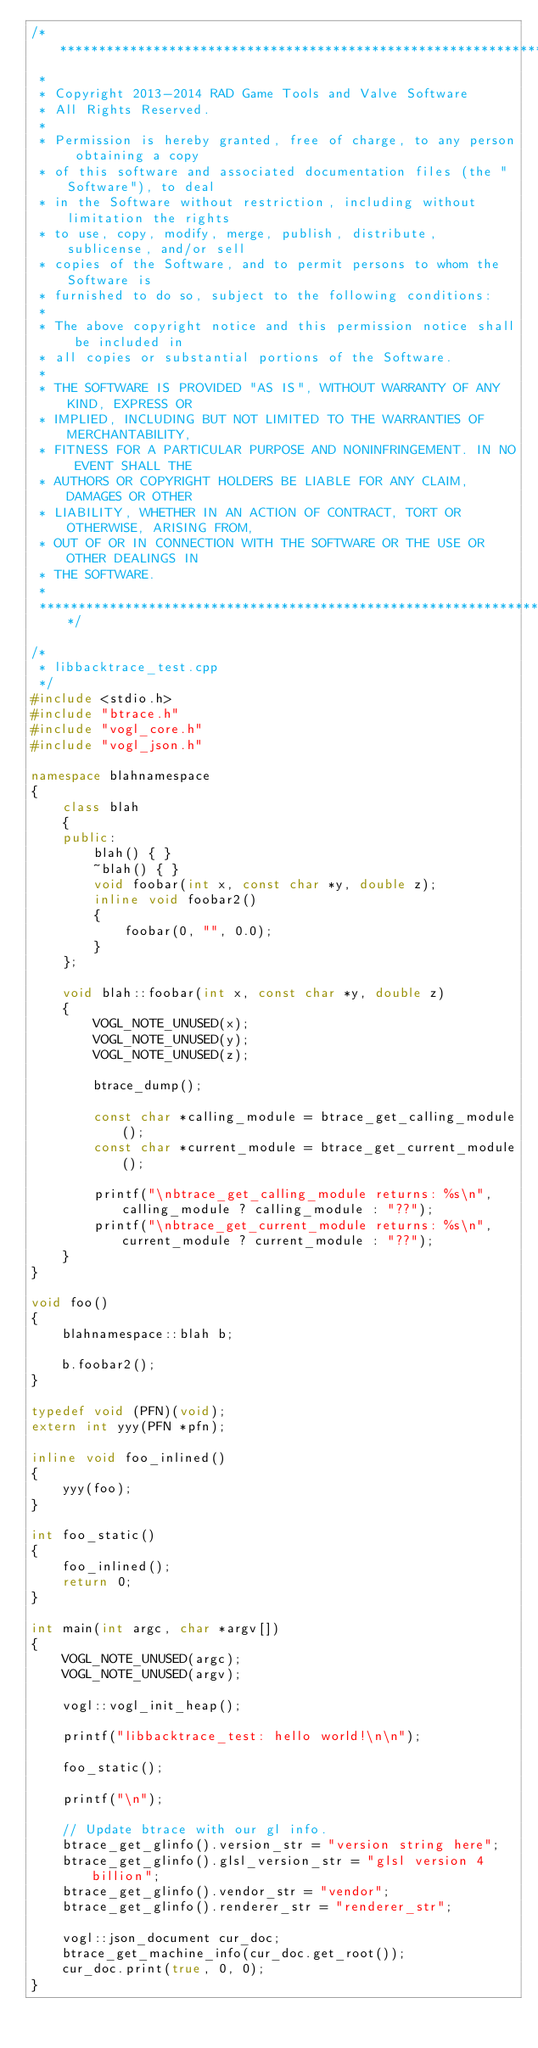<code> <loc_0><loc_0><loc_500><loc_500><_C++_>/**************************************************************************
 *
 * Copyright 2013-2014 RAD Game Tools and Valve Software
 * All Rights Reserved.
 *
 * Permission is hereby granted, free of charge, to any person obtaining a copy
 * of this software and associated documentation files (the "Software"), to deal
 * in the Software without restriction, including without limitation the rights
 * to use, copy, modify, merge, publish, distribute, sublicense, and/or sell
 * copies of the Software, and to permit persons to whom the Software is
 * furnished to do so, subject to the following conditions:
 *
 * The above copyright notice and this permission notice shall be included in
 * all copies or substantial portions of the Software.
 *
 * THE SOFTWARE IS PROVIDED "AS IS", WITHOUT WARRANTY OF ANY KIND, EXPRESS OR
 * IMPLIED, INCLUDING BUT NOT LIMITED TO THE WARRANTIES OF MERCHANTABILITY,
 * FITNESS FOR A PARTICULAR PURPOSE AND NONINFRINGEMENT. IN NO EVENT SHALL THE
 * AUTHORS OR COPYRIGHT HOLDERS BE LIABLE FOR ANY CLAIM, DAMAGES OR OTHER
 * LIABILITY, WHETHER IN AN ACTION OF CONTRACT, TORT OR OTHERWISE, ARISING FROM,
 * OUT OF OR IN CONNECTION WITH THE SOFTWARE OR THE USE OR OTHER DEALINGS IN
 * THE SOFTWARE.
 *
 **************************************************************************/

/*
 * libbacktrace_test.cpp
 */
#include <stdio.h>
#include "btrace.h"
#include "vogl_core.h"
#include "vogl_json.h"

namespace blahnamespace
{
    class blah
    {
    public:
        blah() { }
        ~blah() { }
        void foobar(int x, const char *y, double z);
        inline void foobar2()
        {
            foobar(0, "", 0.0);
        }
    };

    void blah::foobar(int x, const char *y, double z)
    {
        VOGL_NOTE_UNUSED(x);
        VOGL_NOTE_UNUSED(y);
        VOGL_NOTE_UNUSED(z);

        btrace_dump();

        const char *calling_module = btrace_get_calling_module();
        const char *current_module = btrace_get_current_module();

        printf("\nbtrace_get_calling_module returns: %s\n", calling_module ? calling_module : "??");
        printf("\nbtrace_get_current_module returns: %s\n", current_module ? current_module : "??");
    }
}

void foo()
{
    blahnamespace::blah b;

    b.foobar2();
}

typedef void (PFN)(void);
extern int yyy(PFN *pfn);

inline void foo_inlined()
{
    yyy(foo);
}

int foo_static()
{
    foo_inlined();
    return 0;
}

int main(int argc, char *argv[])
{
    VOGL_NOTE_UNUSED(argc);
    VOGL_NOTE_UNUSED(argv);

    vogl::vogl_init_heap();

    printf("libbacktrace_test: hello world!\n\n");

    foo_static();

    printf("\n");

    // Update btrace with our gl info.
    btrace_get_glinfo().version_str = "version string here";
    btrace_get_glinfo().glsl_version_str = "glsl version 4 billion";
    btrace_get_glinfo().vendor_str = "vendor";
    btrace_get_glinfo().renderer_str = "renderer_str";

    vogl::json_document cur_doc;
    btrace_get_machine_info(cur_doc.get_root());
    cur_doc.print(true, 0, 0);
}
</code> 